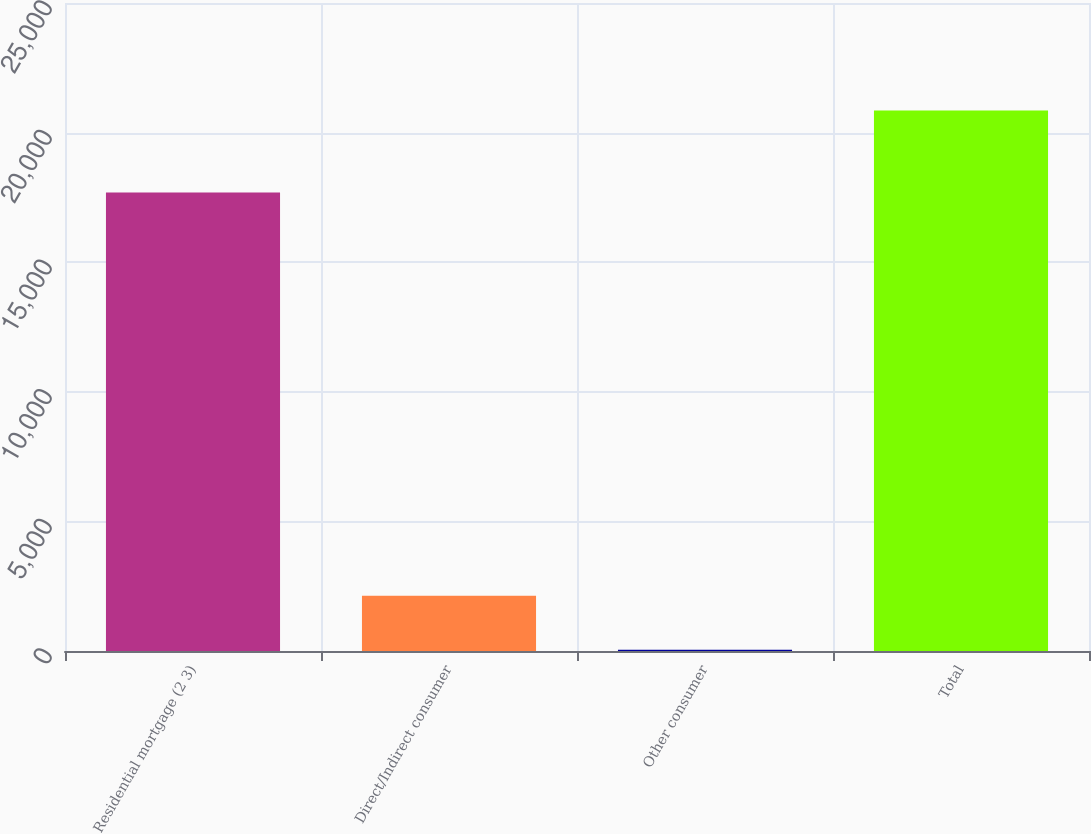<chart> <loc_0><loc_0><loc_500><loc_500><bar_chart><fcel>Residential mortgage (2 3)<fcel>Direct/Indirect consumer<fcel>Other consumer<fcel>Total<nl><fcel>17691<fcel>2128.6<fcel>48<fcel>20854<nl></chart> 